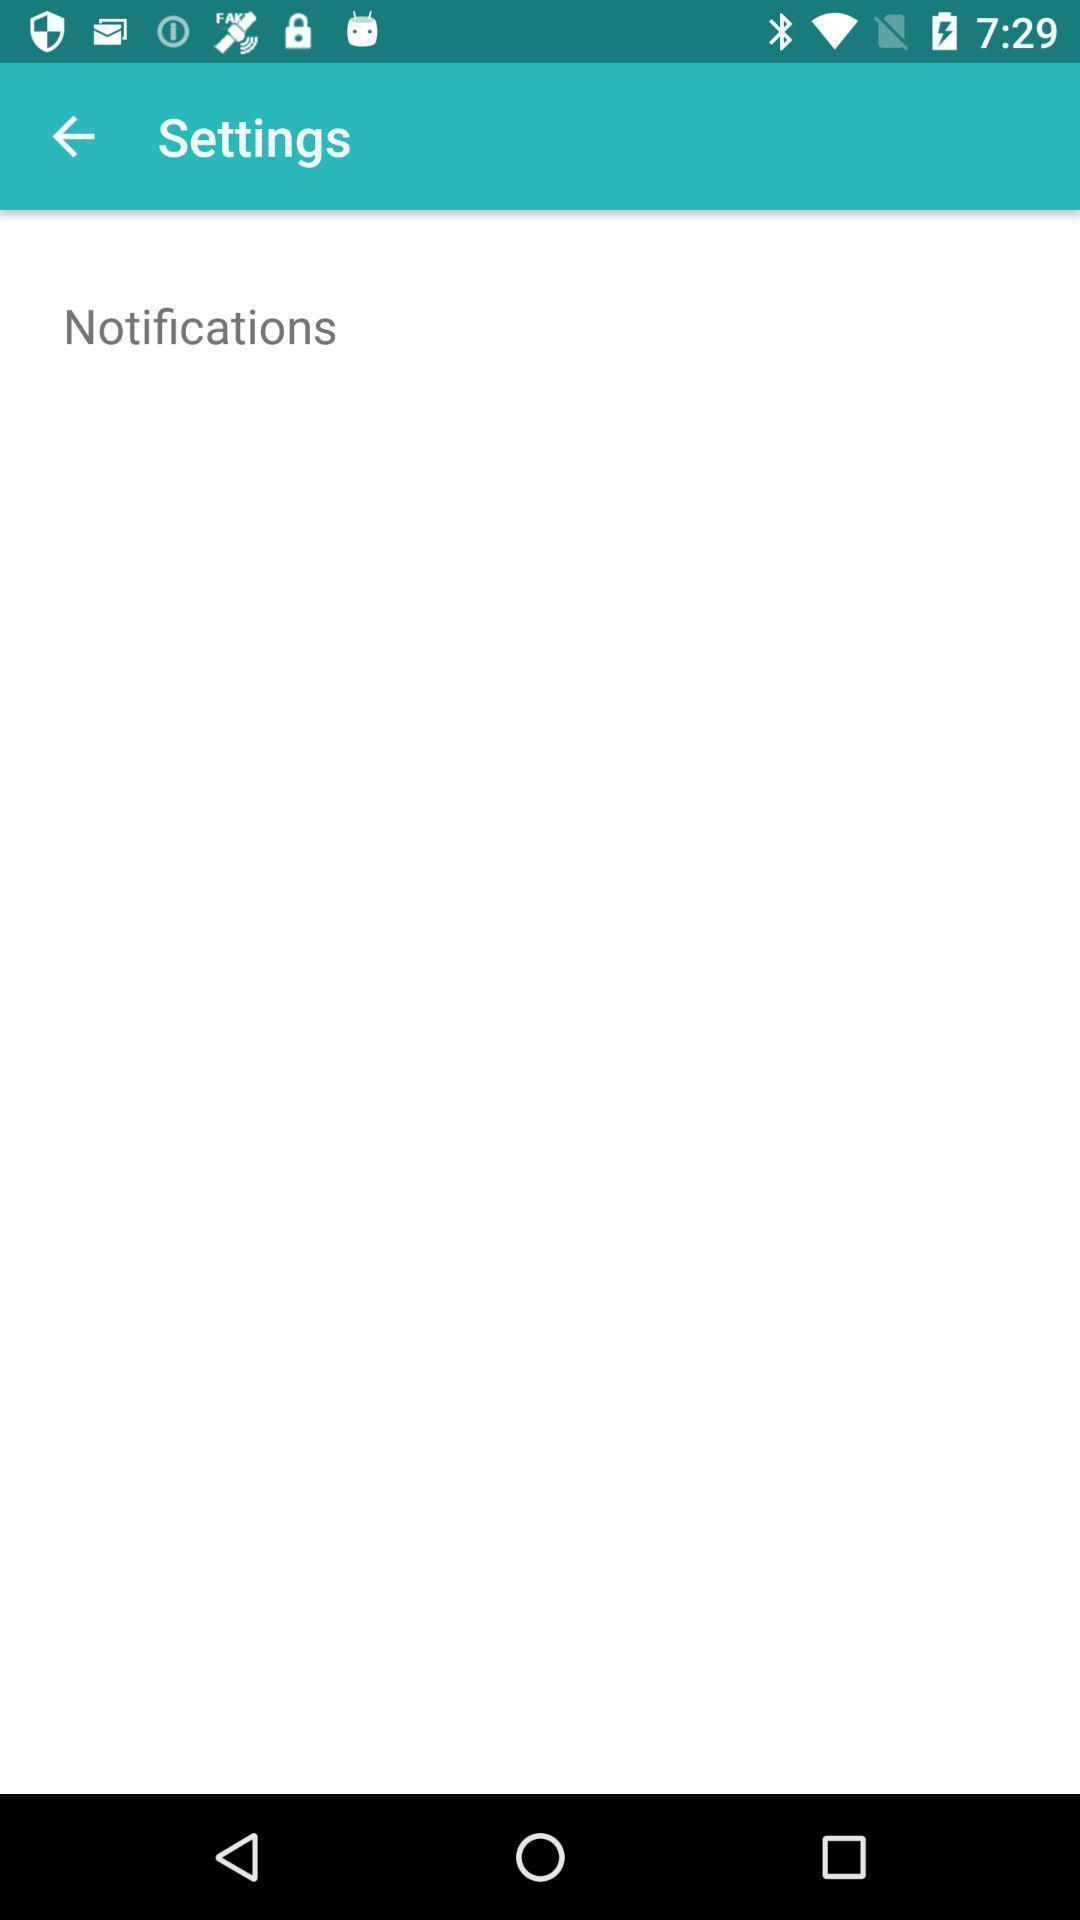Give me a summary of this screen capture. Settings page showing notification. 